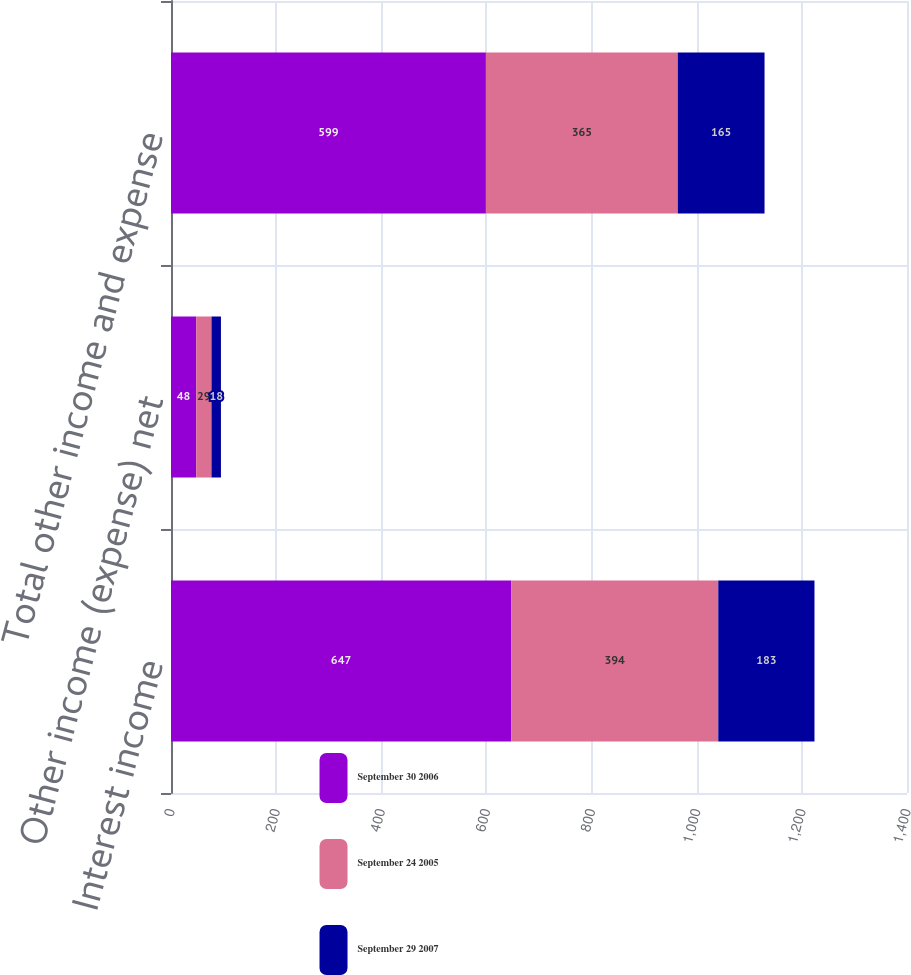<chart> <loc_0><loc_0><loc_500><loc_500><stacked_bar_chart><ecel><fcel>Interest income<fcel>Other income (expense) net<fcel>Total other income and expense<nl><fcel>September 30 2006<fcel>647<fcel>48<fcel>599<nl><fcel>September 24 2005<fcel>394<fcel>29<fcel>365<nl><fcel>September 29 2007<fcel>183<fcel>18<fcel>165<nl></chart> 